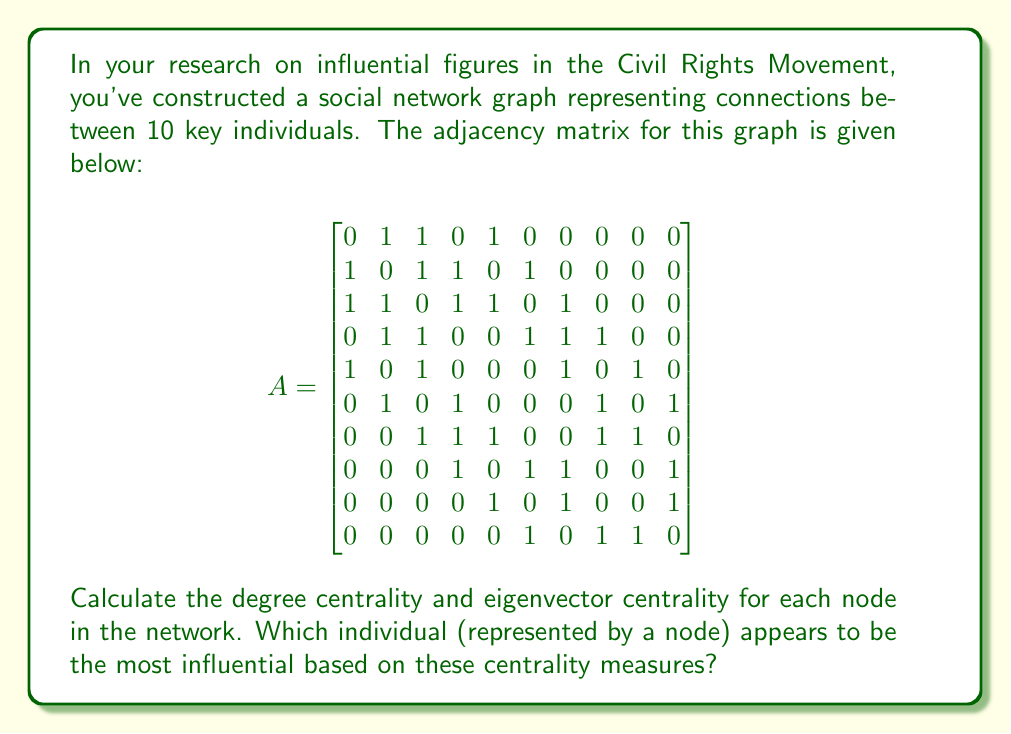Solve this math problem. To solve this problem, we need to calculate two centrality measures: degree centrality and eigenvector centrality.

1. Degree Centrality:
Degree centrality is simply the number of connections each node has. For an undirected graph, it's the sum of each row (or column) in the adjacency matrix.

Degree centralities:
Node 1: 3
Node 2: 4
Node 3: 5
Node 4: 5
Node 5: 4
Node 6: 4
Node 7: 5
Node 8: 4
Node 9: 3
Node 10: 3

2. Eigenvector Centrality:
Eigenvector centrality is based on the principle that connections to high-scoring nodes contribute more to the score of a node than connections to low-scoring nodes. It's calculated using the following steps:

a) Find the largest eigenvalue ($\lambda$) and its corresponding eigenvector for the adjacency matrix.
b) Normalize the eigenvector so that its largest entry is 1.

Using a numerical method (power iteration), we get the following eigenvector centralities (rounded to 4 decimal places):

Node 1: 0.2635
Node 2: 0.3816
Node 3: 0.4641
Node 4: 0.4641
Node 5: 0.3816
Node 6: 0.3816
Node 7: 0.4641
Node 8: 0.3816
Node 9: 0.2635
Node 10: 0.2635

Analyzing the results:

1. Degree Centrality: Nodes 3, 4, and 7 have the highest degree centrality (5 connections each).
2. Eigenvector Centrality: Nodes 3, 4, and 7 have the highest eigenvector centrality (0.4641 each).

Both centrality measures agree that nodes 3, 4, and 7 are the most central in the network, suggesting that these individuals are likely the most influential in this group.
Answer: Based on both degree centrality and eigenvector centrality measures, nodes 3, 4, and 7 appear to be the most influential individuals in the network. They each have the highest degree centrality (5 connections) and the highest eigenvector centrality (0.4641). 